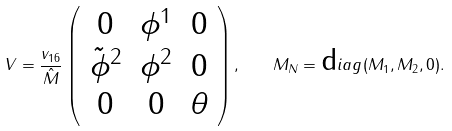<formula> <loc_0><loc_0><loc_500><loc_500>V = \frac { v _ { 1 6 } } { \hat { M } } \left ( \begin{array} { c c c } 0 & \phi ^ { 1 } & 0 \\ \tilde { \phi } ^ { 2 } & \phi ^ { 2 } & 0 \\ 0 & 0 & \theta \end{array} \right ) , \quad M _ { N } = { \mbox d i a g } ( M _ { 1 } , M _ { 2 } , 0 ) .</formula> 